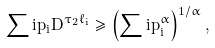Convert formula to latex. <formula><loc_0><loc_0><loc_500><loc_500>\sum i p _ { i } D ^ { \tau _ { 2 } \ell _ { i } } \geq \left ( \sum i p _ { i } ^ { \alpha } \right ) ^ { 1 / \alpha } ,</formula> 